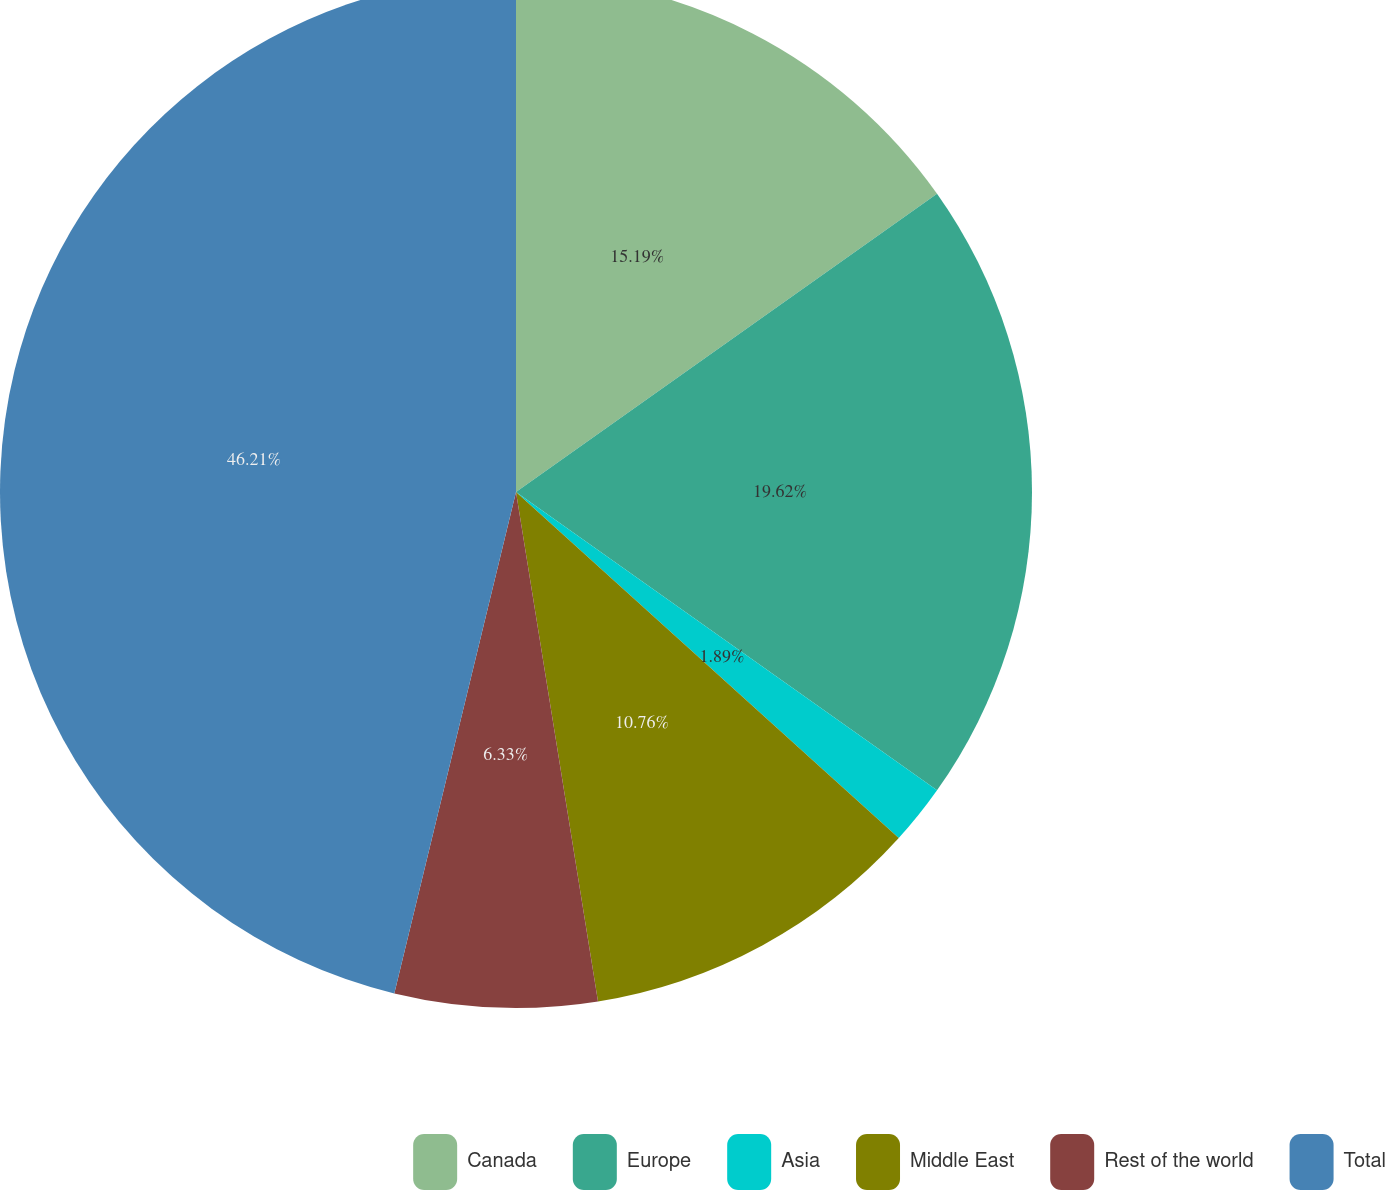Convert chart to OTSL. <chart><loc_0><loc_0><loc_500><loc_500><pie_chart><fcel>Canada<fcel>Europe<fcel>Asia<fcel>Middle East<fcel>Rest of the world<fcel>Total<nl><fcel>15.19%<fcel>19.62%<fcel>1.89%<fcel>10.76%<fcel>6.33%<fcel>46.21%<nl></chart> 